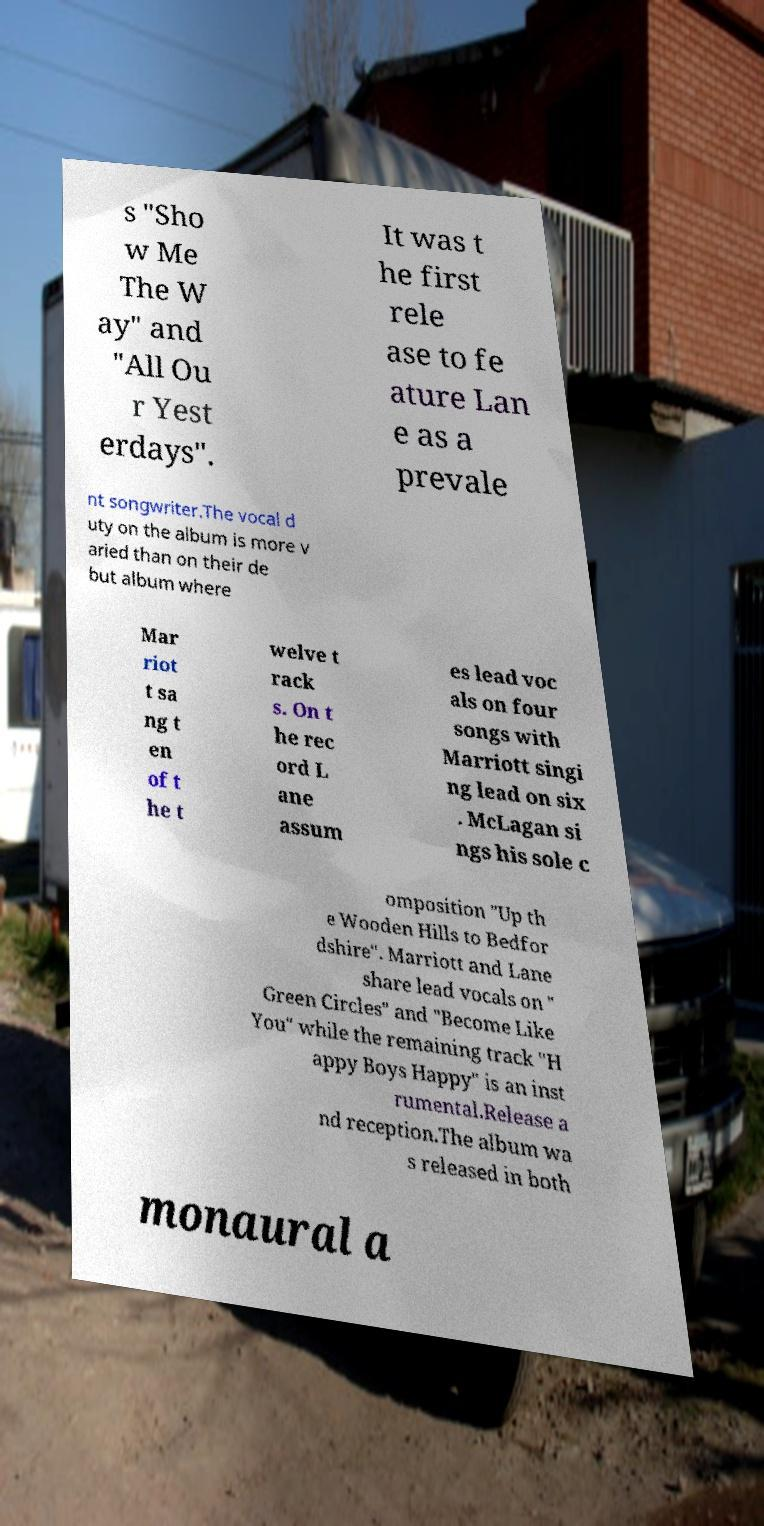There's text embedded in this image that I need extracted. Can you transcribe it verbatim? s "Sho w Me The W ay" and "All Ou r Yest erdays". It was t he first rele ase to fe ature Lan e as a prevale nt songwriter.The vocal d uty on the album is more v aried than on their de but album where Mar riot t sa ng t en of t he t welve t rack s. On t he rec ord L ane assum es lead voc als on four songs with Marriott singi ng lead on six . McLagan si ngs his sole c omposition "Up th e Wooden Hills to Bedfor dshire". Marriott and Lane share lead vocals on " Green Circles" and "Become Like You" while the remaining track "H appy Boys Happy" is an inst rumental.Release a nd reception.The album wa s released in both monaural a 